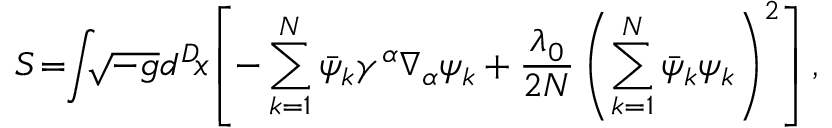Convert formula to latex. <formula><loc_0><loc_0><loc_500><loc_500>S \, = \, \int \, \sqrt { - g } d ^ { D } \, x \, \left [ - \sum _ { k = 1 } ^ { N } \bar { \psi } _ { k } \gamma ^ { \alpha } \nabla _ { \alpha } \psi _ { k } + \frac { \lambda _ { 0 } } { 2 N } \left ( \sum _ { k = 1 } ^ { N } \bar { \psi } _ { k } \psi _ { k } \right ) ^ { 2 } \right ] ,</formula> 